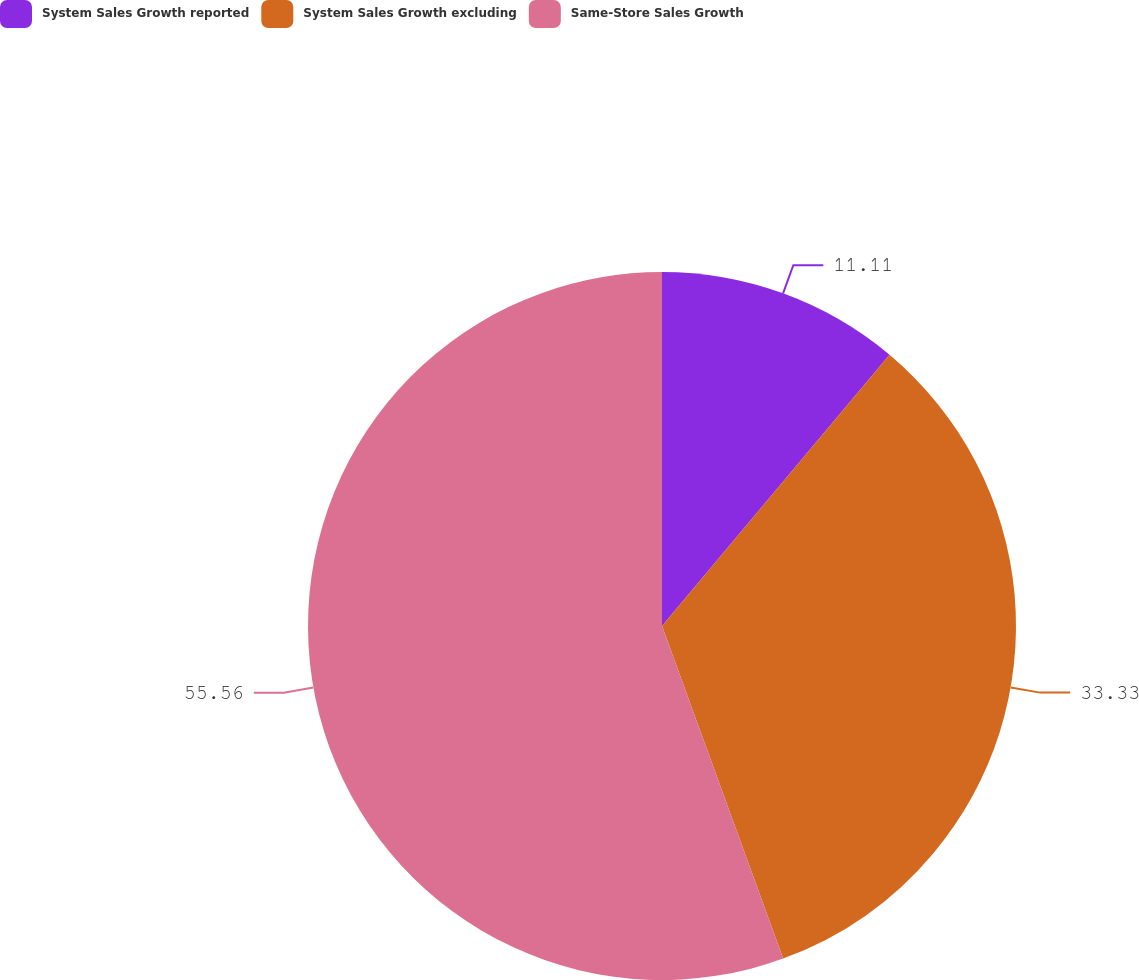Convert chart. <chart><loc_0><loc_0><loc_500><loc_500><pie_chart><fcel>System Sales Growth reported<fcel>System Sales Growth excluding<fcel>Same-Store Sales Growth<nl><fcel>11.11%<fcel>33.33%<fcel>55.56%<nl></chart> 